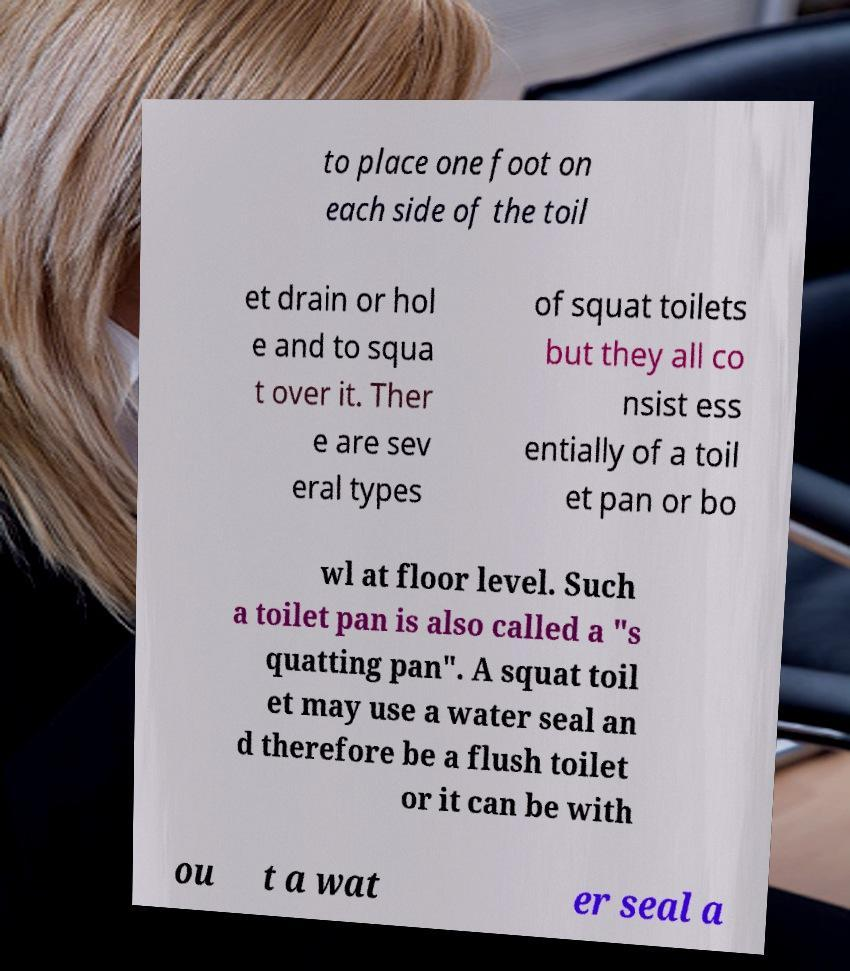Can you accurately transcribe the text from the provided image for me? to place one foot on each side of the toil et drain or hol e and to squa t over it. Ther e are sev eral types of squat toilets but they all co nsist ess entially of a toil et pan or bo wl at floor level. Such a toilet pan is also called a "s quatting pan". A squat toil et may use a water seal an d therefore be a flush toilet or it can be with ou t a wat er seal a 